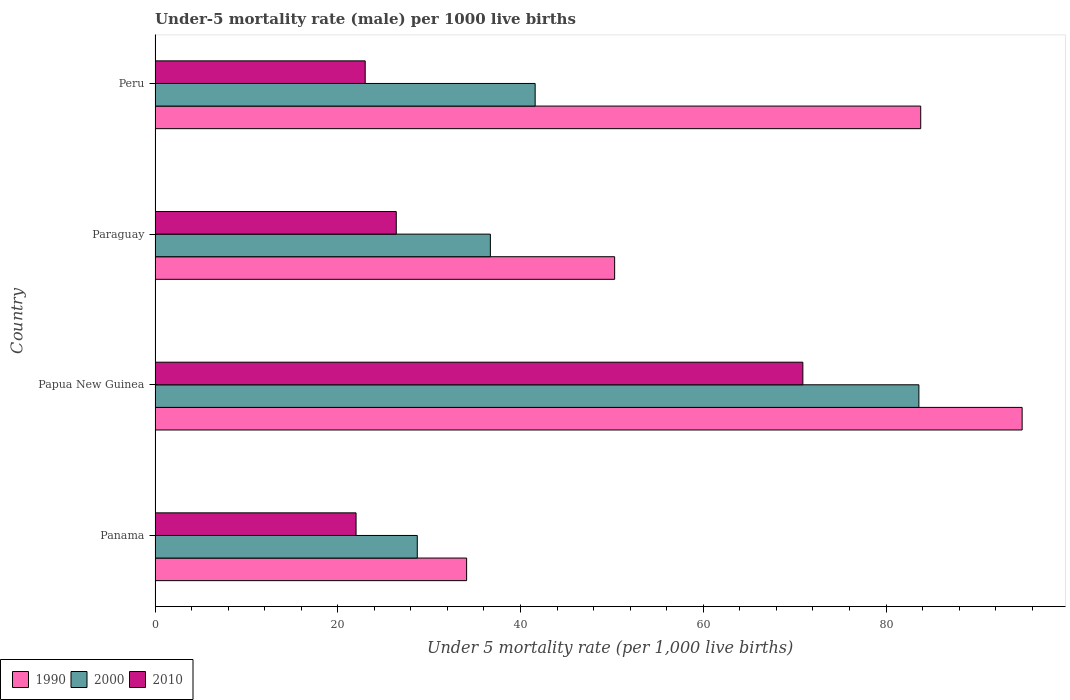How many different coloured bars are there?
Offer a terse response. 3. How many bars are there on the 1st tick from the top?
Provide a short and direct response. 3. What is the label of the 2nd group of bars from the top?
Provide a short and direct response. Paraguay. What is the under-five mortality rate in 1990 in Peru?
Make the answer very short. 83.8. Across all countries, what is the maximum under-five mortality rate in 2010?
Your response must be concise. 70.9. Across all countries, what is the minimum under-five mortality rate in 2010?
Provide a succinct answer. 22. In which country was the under-five mortality rate in 2010 maximum?
Your answer should be compact. Papua New Guinea. In which country was the under-five mortality rate in 2010 minimum?
Your answer should be very brief. Panama. What is the total under-five mortality rate in 1990 in the graph?
Keep it short and to the point. 263.1. What is the difference between the under-five mortality rate in 2000 in Papua New Guinea and that in Peru?
Provide a succinct answer. 42. What is the difference between the under-five mortality rate in 1990 in Papua New Guinea and the under-five mortality rate in 2010 in Paraguay?
Offer a very short reply. 68.5. What is the average under-five mortality rate in 2000 per country?
Provide a succinct answer. 47.65. What is the difference between the under-five mortality rate in 2000 and under-five mortality rate in 1990 in Peru?
Give a very brief answer. -42.2. What is the ratio of the under-five mortality rate in 1990 in Papua New Guinea to that in Paraguay?
Keep it short and to the point. 1.89. Is the under-five mortality rate in 1990 in Papua New Guinea less than that in Peru?
Offer a terse response. No. Is the difference between the under-five mortality rate in 2000 in Panama and Papua New Guinea greater than the difference between the under-five mortality rate in 1990 in Panama and Papua New Guinea?
Keep it short and to the point. Yes. What is the difference between the highest and the second highest under-five mortality rate in 1990?
Make the answer very short. 11.1. What is the difference between the highest and the lowest under-five mortality rate in 1990?
Keep it short and to the point. 60.8. Is the sum of the under-five mortality rate in 2010 in Papua New Guinea and Peru greater than the maximum under-five mortality rate in 1990 across all countries?
Offer a very short reply. No. How many bars are there?
Your response must be concise. 12. What is the difference between two consecutive major ticks on the X-axis?
Make the answer very short. 20. Does the graph contain any zero values?
Your answer should be compact. No. Does the graph contain grids?
Provide a short and direct response. No. Where does the legend appear in the graph?
Make the answer very short. Bottom left. How many legend labels are there?
Offer a very short reply. 3. How are the legend labels stacked?
Offer a very short reply. Horizontal. What is the title of the graph?
Ensure brevity in your answer.  Under-5 mortality rate (male) per 1000 live births. Does "1971" appear as one of the legend labels in the graph?
Provide a succinct answer. No. What is the label or title of the X-axis?
Provide a succinct answer. Under 5 mortality rate (per 1,0 live births). What is the Under 5 mortality rate (per 1,000 live births) in 1990 in Panama?
Offer a very short reply. 34.1. What is the Under 5 mortality rate (per 1,000 live births) of 2000 in Panama?
Keep it short and to the point. 28.7. What is the Under 5 mortality rate (per 1,000 live births) in 1990 in Papua New Guinea?
Your answer should be very brief. 94.9. What is the Under 5 mortality rate (per 1,000 live births) in 2000 in Papua New Guinea?
Make the answer very short. 83.6. What is the Under 5 mortality rate (per 1,000 live births) of 2010 in Papua New Guinea?
Your response must be concise. 70.9. What is the Under 5 mortality rate (per 1,000 live births) in 1990 in Paraguay?
Give a very brief answer. 50.3. What is the Under 5 mortality rate (per 1,000 live births) in 2000 in Paraguay?
Ensure brevity in your answer.  36.7. What is the Under 5 mortality rate (per 1,000 live births) in 2010 in Paraguay?
Provide a succinct answer. 26.4. What is the Under 5 mortality rate (per 1,000 live births) in 1990 in Peru?
Provide a short and direct response. 83.8. What is the Under 5 mortality rate (per 1,000 live births) of 2000 in Peru?
Provide a short and direct response. 41.6. Across all countries, what is the maximum Under 5 mortality rate (per 1,000 live births) in 1990?
Give a very brief answer. 94.9. Across all countries, what is the maximum Under 5 mortality rate (per 1,000 live births) of 2000?
Give a very brief answer. 83.6. Across all countries, what is the maximum Under 5 mortality rate (per 1,000 live births) of 2010?
Provide a succinct answer. 70.9. Across all countries, what is the minimum Under 5 mortality rate (per 1,000 live births) in 1990?
Make the answer very short. 34.1. Across all countries, what is the minimum Under 5 mortality rate (per 1,000 live births) in 2000?
Your answer should be very brief. 28.7. What is the total Under 5 mortality rate (per 1,000 live births) of 1990 in the graph?
Ensure brevity in your answer.  263.1. What is the total Under 5 mortality rate (per 1,000 live births) in 2000 in the graph?
Your response must be concise. 190.6. What is the total Under 5 mortality rate (per 1,000 live births) of 2010 in the graph?
Your response must be concise. 142.3. What is the difference between the Under 5 mortality rate (per 1,000 live births) in 1990 in Panama and that in Papua New Guinea?
Ensure brevity in your answer.  -60.8. What is the difference between the Under 5 mortality rate (per 1,000 live births) of 2000 in Panama and that in Papua New Guinea?
Make the answer very short. -54.9. What is the difference between the Under 5 mortality rate (per 1,000 live births) of 2010 in Panama and that in Papua New Guinea?
Provide a short and direct response. -48.9. What is the difference between the Under 5 mortality rate (per 1,000 live births) in 1990 in Panama and that in Paraguay?
Offer a very short reply. -16.2. What is the difference between the Under 5 mortality rate (per 1,000 live births) of 2000 in Panama and that in Paraguay?
Your response must be concise. -8. What is the difference between the Under 5 mortality rate (per 1,000 live births) in 2010 in Panama and that in Paraguay?
Make the answer very short. -4.4. What is the difference between the Under 5 mortality rate (per 1,000 live births) in 1990 in Panama and that in Peru?
Offer a very short reply. -49.7. What is the difference between the Under 5 mortality rate (per 1,000 live births) in 2010 in Panama and that in Peru?
Your response must be concise. -1. What is the difference between the Under 5 mortality rate (per 1,000 live births) in 1990 in Papua New Guinea and that in Paraguay?
Your answer should be compact. 44.6. What is the difference between the Under 5 mortality rate (per 1,000 live births) in 2000 in Papua New Guinea and that in Paraguay?
Keep it short and to the point. 46.9. What is the difference between the Under 5 mortality rate (per 1,000 live births) of 2010 in Papua New Guinea and that in Paraguay?
Keep it short and to the point. 44.5. What is the difference between the Under 5 mortality rate (per 1,000 live births) of 1990 in Papua New Guinea and that in Peru?
Provide a succinct answer. 11.1. What is the difference between the Under 5 mortality rate (per 1,000 live births) in 2010 in Papua New Guinea and that in Peru?
Your answer should be compact. 47.9. What is the difference between the Under 5 mortality rate (per 1,000 live births) of 1990 in Paraguay and that in Peru?
Provide a succinct answer. -33.5. What is the difference between the Under 5 mortality rate (per 1,000 live births) in 2000 in Paraguay and that in Peru?
Keep it short and to the point. -4.9. What is the difference between the Under 5 mortality rate (per 1,000 live births) in 1990 in Panama and the Under 5 mortality rate (per 1,000 live births) in 2000 in Papua New Guinea?
Provide a succinct answer. -49.5. What is the difference between the Under 5 mortality rate (per 1,000 live births) of 1990 in Panama and the Under 5 mortality rate (per 1,000 live births) of 2010 in Papua New Guinea?
Ensure brevity in your answer.  -36.8. What is the difference between the Under 5 mortality rate (per 1,000 live births) in 2000 in Panama and the Under 5 mortality rate (per 1,000 live births) in 2010 in Papua New Guinea?
Offer a very short reply. -42.2. What is the difference between the Under 5 mortality rate (per 1,000 live births) in 1990 in Panama and the Under 5 mortality rate (per 1,000 live births) in 2010 in Paraguay?
Ensure brevity in your answer.  7.7. What is the difference between the Under 5 mortality rate (per 1,000 live births) in 2000 in Panama and the Under 5 mortality rate (per 1,000 live births) in 2010 in Paraguay?
Offer a terse response. 2.3. What is the difference between the Under 5 mortality rate (per 1,000 live births) of 1990 in Panama and the Under 5 mortality rate (per 1,000 live births) of 2000 in Peru?
Your answer should be compact. -7.5. What is the difference between the Under 5 mortality rate (per 1,000 live births) in 2000 in Panama and the Under 5 mortality rate (per 1,000 live births) in 2010 in Peru?
Make the answer very short. 5.7. What is the difference between the Under 5 mortality rate (per 1,000 live births) in 1990 in Papua New Guinea and the Under 5 mortality rate (per 1,000 live births) in 2000 in Paraguay?
Make the answer very short. 58.2. What is the difference between the Under 5 mortality rate (per 1,000 live births) of 1990 in Papua New Guinea and the Under 5 mortality rate (per 1,000 live births) of 2010 in Paraguay?
Your answer should be very brief. 68.5. What is the difference between the Under 5 mortality rate (per 1,000 live births) in 2000 in Papua New Guinea and the Under 5 mortality rate (per 1,000 live births) in 2010 in Paraguay?
Give a very brief answer. 57.2. What is the difference between the Under 5 mortality rate (per 1,000 live births) of 1990 in Papua New Guinea and the Under 5 mortality rate (per 1,000 live births) of 2000 in Peru?
Ensure brevity in your answer.  53.3. What is the difference between the Under 5 mortality rate (per 1,000 live births) of 1990 in Papua New Guinea and the Under 5 mortality rate (per 1,000 live births) of 2010 in Peru?
Your answer should be very brief. 71.9. What is the difference between the Under 5 mortality rate (per 1,000 live births) in 2000 in Papua New Guinea and the Under 5 mortality rate (per 1,000 live births) in 2010 in Peru?
Your response must be concise. 60.6. What is the difference between the Under 5 mortality rate (per 1,000 live births) of 1990 in Paraguay and the Under 5 mortality rate (per 1,000 live births) of 2000 in Peru?
Keep it short and to the point. 8.7. What is the difference between the Under 5 mortality rate (per 1,000 live births) of 1990 in Paraguay and the Under 5 mortality rate (per 1,000 live births) of 2010 in Peru?
Make the answer very short. 27.3. What is the average Under 5 mortality rate (per 1,000 live births) of 1990 per country?
Provide a succinct answer. 65.78. What is the average Under 5 mortality rate (per 1,000 live births) in 2000 per country?
Ensure brevity in your answer.  47.65. What is the average Under 5 mortality rate (per 1,000 live births) of 2010 per country?
Your answer should be very brief. 35.58. What is the difference between the Under 5 mortality rate (per 1,000 live births) of 1990 and Under 5 mortality rate (per 1,000 live births) of 2000 in Papua New Guinea?
Make the answer very short. 11.3. What is the difference between the Under 5 mortality rate (per 1,000 live births) in 1990 and Under 5 mortality rate (per 1,000 live births) in 2010 in Papua New Guinea?
Offer a terse response. 24. What is the difference between the Under 5 mortality rate (per 1,000 live births) of 2000 and Under 5 mortality rate (per 1,000 live births) of 2010 in Papua New Guinea?
Give a very brief answer. 12.7. What is the difference between the Under 5 mortality rate (per 1,000 live births) of 1990 and Under 5 mortality rate (per 1,000 live births) of 2000 in Paraguay?
Provide a short and direct response. 13.6. What is the difference between the Under 5 mortality rate (per 1,000 live births) of 1990 and Under 5 mortality rate (per 1,000 live births) of 2010 in Paraguay?
Ensure brevity in your answer.  23.9. What is the difference between the Under 5 mortality rate (per 1,000 live births) in 2000 and Under 5 mortality rate (per 1,000 live births) in 2010 in Paraguay?
Make the answer very short. 10.3. What is the difference between the Under 5 mortality rate (per 1,000 live births) in 1990 and Under 5 mortality rate (per 1,000 live births) in 2000 in Peru?
Give a very brief answer. 42.2. What is the difference between the Under 5 mortality rate (per 1,000 live births) in 1990 and Under 5 mortality rate (per 1,000 live births) in 2010 in Peru?
Provide a succinct answer. 60.8. What is the difference between the Under 5 mortality rate (per 1,000 live births) in 2000 and Under 5 mortality rate (per 1,000 live births) in 2010 in Peru?
Ensure brevity in your answer.  18.6. What is the ratio of the Under 5 mortality rate (per 1,000 live births) in 1990 in Panama to that in Papua New Guinea?
Give a very brief answer. 0.36. What is the ratio of the Under 5 mortality rate (per 1,000 live births) in 2000 in Panama to that in Papua New Guinea?
Your answer should be very brief. 0.34. What is the ratio of the Under 5 mortality rate (per 1,000 live births) in 2010 in Panama to that in Papua New Guinea?
Your answer should be very brief. 0.31. What is the ratio of the Under 5 mortality rate (per 1,000 live births) in 1990 in Panama to that in Paraguay?
Your response must be concise. 0.68. What is the ratio of the Under 5 mortality rate (per 1,000 live births) of 2000 in Panama to that in Paraguay?
Your response must be concise. 0.78. What is the ratio of the Under 5 mortality rate (per 1,000 live births) of 1990 in Panama to that in Peru?
Your answer should be compact. 0.41. What is the ratio of the Under 5 mortality rate (per 1,000 live births) of 2000 in Panama to that in Peru?
Give a very brief answer. 0.69. What is the ratio of the Under 5 mortality rate (per 1,000 live births) of 2010 in Panama to that in Peru?
Offer a very short reply. 0.96. What is the ratio of the Under 5 mortality rate (per 1,000 live births) of 1990 in Papua New Guinea to that in Paraguay?
Make the answer very short. 1.89. What is the ratio of the Under 5 mortality rate (per 1,000 live births) in 2000 in Papua New Guinea to that in Paraguay?
Provide a succinct answer. 2.28. What is the ratio of the Under 5 mortality rate (per 1,000 live births) in 2010 in Papua New Guinea to that in Paraguay?
Your answer should be compact. 2.69. What is the ratio of the Under 5 mortality rate (per 1,000 live births) of 1990 in Papua New Guinea to that in Peru?
Provide a short and direct response. 1.13. What is the ratio of the Under 5 mortality rate (per 1,000 live births) in 2000 in Papua New Guinea to that in Peru?
Offer a very short reply. 2.01. What is the ratio of the Under 5 mortality rate (per 1,000 live births) of 2010 in Papua New Guinea to that in Peru?
Your answer should be compact. 3.08. What is the ratio of the Under 5 mortality rate (per 1,000 live births) of 1990 in Paraguay to that in Peru?
Your response must be concise. 0.6. What is the ratio of the Under 5 mortality rate (per 1,000 live births) in 2000 in Paraguay to that in Peru?
Your answer should be very brief. 0.88. What is the ratio of the Under 5 mortality rate (per 1,000 live births) of 2010 in Paraguay to that in Peru?
Offer a very short reply. 1.15. What is the difference between the highest and the second highest Under 5 mortality rate (per 1,000 live births) of 1990?
Make the answer very short. 11.1. What is the difference between the highest and the second highest Under 5 mortality rate (per 1,000 live births) of 2000?
Make the answer very short. 42. What is the difference between the highest and the second highest Under 5 mortality rate (per 1,000 live births) in 2010?
Give a very brief answer. 44.5. What is the difference between the highest and the lowest Under 5 mortality rate (per 1,000 live births) of 1990?
Give a very brief answer. 60.8. What is the difference between the highest and the lowest Under 5 mortality rate (per 1,000 live births) in 2000?
Offer a very short reply. 54.9. What is the difference between the highest and the lowest Under 5 mortality rate (per 1,000 live births) of 2010?
Make the answer very short. 48.9. 